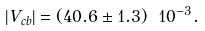<formula> <loc_0><loc_0><loc_500><loc_500>| V _ { c b } | = ( 4 0 . 6 \pm 1 . 3 ) \ 1 0 ^ { - 3 } .</formula> 